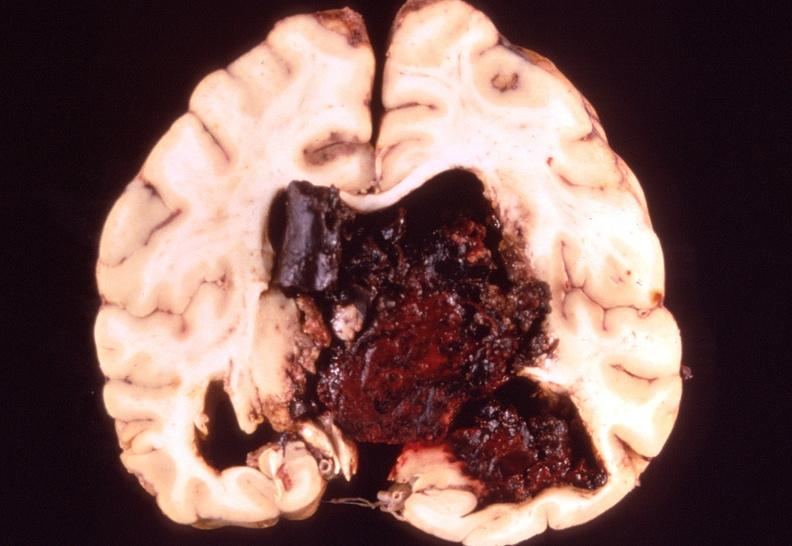s underdevelopment present?
Answer the question using a single word or phrase. No 